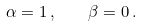<formula> <loc_0><loc_0><loc_500><loc_500>\alpha = 1 \, , \quad \beta = 0 \, .</formula> 